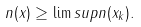Convert formula to latex. <formula><loc_0><loc_0><loc_500><loc_500>n ( x ) \geq \lim s u p n ( x _ { k } ) .</formula> 